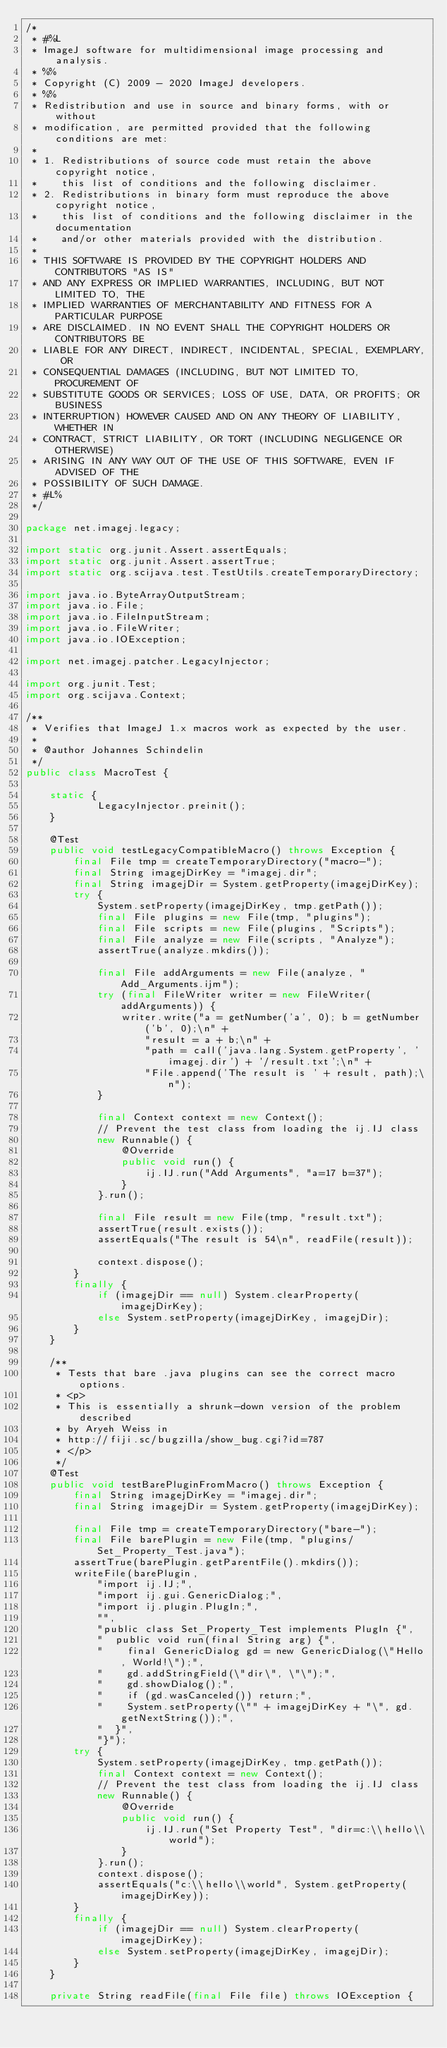Convert code to text. <code><loc_0><loc_0><loc_500><loc_500><_Java_>/*
 * #%L
 * ImageJ software for multidimensional image processing and analysis.
 * %%
 * Copyright (C) 2009 - 2020 ImageJ developers.
 * %%
 * Redistribution and use in source and binary forms, with or without
 * modification, are permitted provided that the following conditions are met:
 * 
 * 1. Redistributions of source code must retain the above copyright notice,
 *    this list of conditions and the following disclaimer.
 * 2. Redistributions in binary form must reproduce the above copyright notice,
 *    this list of conditions and the following disclaimer in the documentation
 *    and/or other materials provided with the distribution.
 * 
 * THIS SOFTWARE IS PROVIDED BY THE COPYRIGHT HOLDERS AND CONTRIBUTORS "AS IS"
 * AND ANY EXPRESS OR IMPLIED WARRANTIES, INCLUDING, BUT NOT LIMITED TO, THE
 * IMPLIED WARRANTIES OF MERCHANTABILITY AND FITNESS FOR A PARTICULAR PURPOSE
 * ARE DISCLAIMED. IN NO EVENT SHALL THE COPYRIGHT HOLDERS OR CONTRIBUTORS BE
 * LIABLE FOR ANY DIRECT, INDIRECT, INCIDENTAL, SPECIAL, EXEMPLARY, OR
 * CONSEQUENTIAL DAMAGES (INCLUDING, BUT NOT LIMITED TO, PROCUREMENT OF
 * SUBSTITUTE GOODS OR SERVICES; LOSS OF USE, DATA, OR PROFITS; OR BUSINESS
 * INTERRUPTION) HOWEVER CAUSED AND ON ANY THEORY OF LIABILITY, WHETHER IN
 * CONTRACT, STRICT LIABILITY, OR TORT (INCLUDING NEGLIGENCE OR OTHERWISE)
 * ARISING IN ANY WAY OUT OF THE USE OF THIS SOFTWARE, EVEN IF ADVISED OF THE
 * POSSIBILITY OF SUCH DAMAGE.
 * #L%
 */

package net.imagej.legacy;

import static org.junit.Assert.assertEquals;
import static org.junit.Assert.assertTrue;
import static org.scijava.test.TestUtils.createTemporaryDirectory;

import java.io.ByteArrayOutputStream;
import java.io.File;
import java.io.FileInputStream;
import java.io.FileWriter;
import java.io.IOException;

import net.imagej.patcher.LegacyInjector;

import org.junit.Test;
import org.scijava.Context;

/**
 * Verifies that ImageJ 1.x macros work as expected by the user.
 * 
 * @author Johannes Schindelin
 */
public class MacroTest {

	static {
			LegacyInjector.preinit();
	}

	@Test
	public void testLegacyCompatibleMacro() throws Exception {
		final File tmp = createTemporaryDirectory("macro-");
		final String imagejDirKey = "imagej.dir";
		final String imagejDir = System.getProperty(imagejDirKey);
		try {
			System.setProperty(imagejDirKey, tmp.getPath());
			final File plugins = new File(tmp, "plugins");
			final File scripts = new File(plugins, "Scripts");
			final File analyze = new File(scripts, "Analyze");
			assertTrue(analyze.mkdirs());

			final File addArguments = new File(analyze, "Add_Arguments.ijm");
			try (final FileWriter writer = new FileWriter(addArguments)) {
				writer.write("a = getNumber('a', 0); b = getNumber('b', 0);\n" +
					"result = a + b;\n" +
					"path = call('java.lang.System.getProperty', 'imagej.dir') + '/result.txt';\n" +
					"File.append('The result is ' + result, path);\n");
			}

			final Context context = new Context();
			// Prevent the test class from loading the ij.IJ class
			new Runnable() {
				@Override
				public void run() {
					ij.IJ.run("Add Arguments", "a=17 b=37");
				}
			}.run();

			final File result = new File(tmp, "result.txt");
			assertTrue(result.exists());
			assertEquals("The result is 54\n", readFile(result));

			context.dispose();
		}
		finally {
			if (imagejDir == null) System.clearProperty(imagejDirKey);
			else System.setProperty(imagejDirKey, imagejDir);
		}
	}

	/**
	 * Tests that bare .java plugins can see the correct macro options.
	 * <p>
	 * This is essentially a shrunk-down version of the problem described
	 * by Aryeh Weiss in
	 * http://fiji.sc/bugzilla/show_bug.cgi?id=787
	 * </p>
	 */
	@Test
	public void testBarePluginFromMacro() throws Exception {
		final String imagejDirKey = "imagej.dir";
		final String imagejDir = System.getProperty(imagejDirKey);

		final File tmp = createTemporaryDirectory("bare-");
		final File barePlugin = new File(tmp, "plugins/Set_Property_Test.java");
		assertTrue(barePlugin.getParentFile().mkdirs());
		writeFile(barePlugin,
			"import ij.IJ;",
			"import ij.gui.GenericDialog;",
			"import ij.plugin.PlugIn;",
			"",
			"public class Set_Property_Test implements PlugIn {",
			"  public void run(final String arg) {",
			"    final GenericDialog gd = new GenericDialog(\"Hello, World!\");",
			"    gd.addStringField(\"dir\", \"\");",
			"    gd.showDialog();",
			"    if (gd.wasCanceled()) return;",
			"    System.setProperty(\"" + imagejDirKey + "\", gd.getNextString());",
			"  }",
			"}");
		try {
			System.setProperty(imagejDirKey, tmp.getPath());
			final Context context = new Context();
			// Prevent the test class from loading the ij.IJ class
			new Runnable() {
				@Override
				public void run() {
					ij.IJ.run("Set Property Test", "dir=c:\\hello\\world");
				}
			}.run();
			context.dispose();
			assertEquals("c:\\hello\\world", System.getProperty(imagejDirKey));
		}
		finally {
			if (imagejDir == null) System.clearProperty(imagejDirKey);
			else System.setProperty(imagejDirKey, imagejDir);
		}
	}

	private String readFile(final File file) throws IOException {</code> 